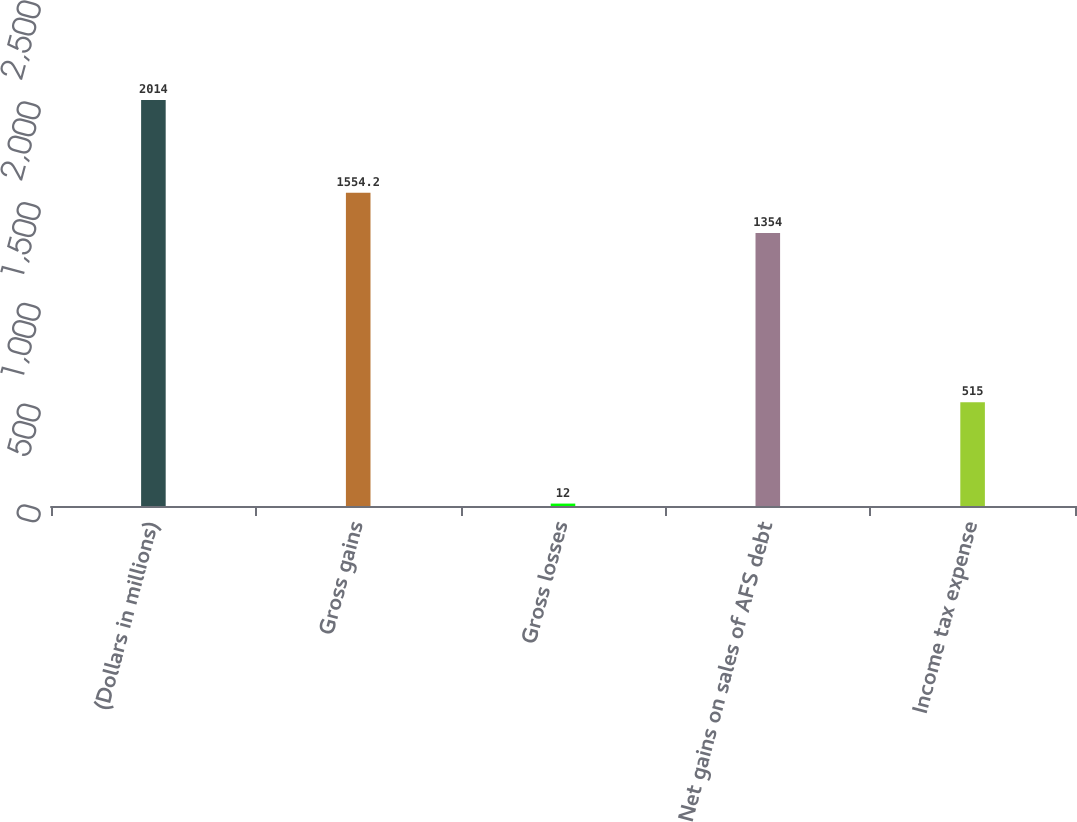<chart> <loc_0><loc_0><loc_500><loc_500><bar_chart><fcel>(Dollars in millions)<fcel>Gross gains<fcel>Gross losses<fcel>Net gains on sales of AFS debt<fcel>Income tax expense<nl><fcel>2014<fcel>1554.2<fcel>12<fcel>1354<fcel>515<nl></chart> 